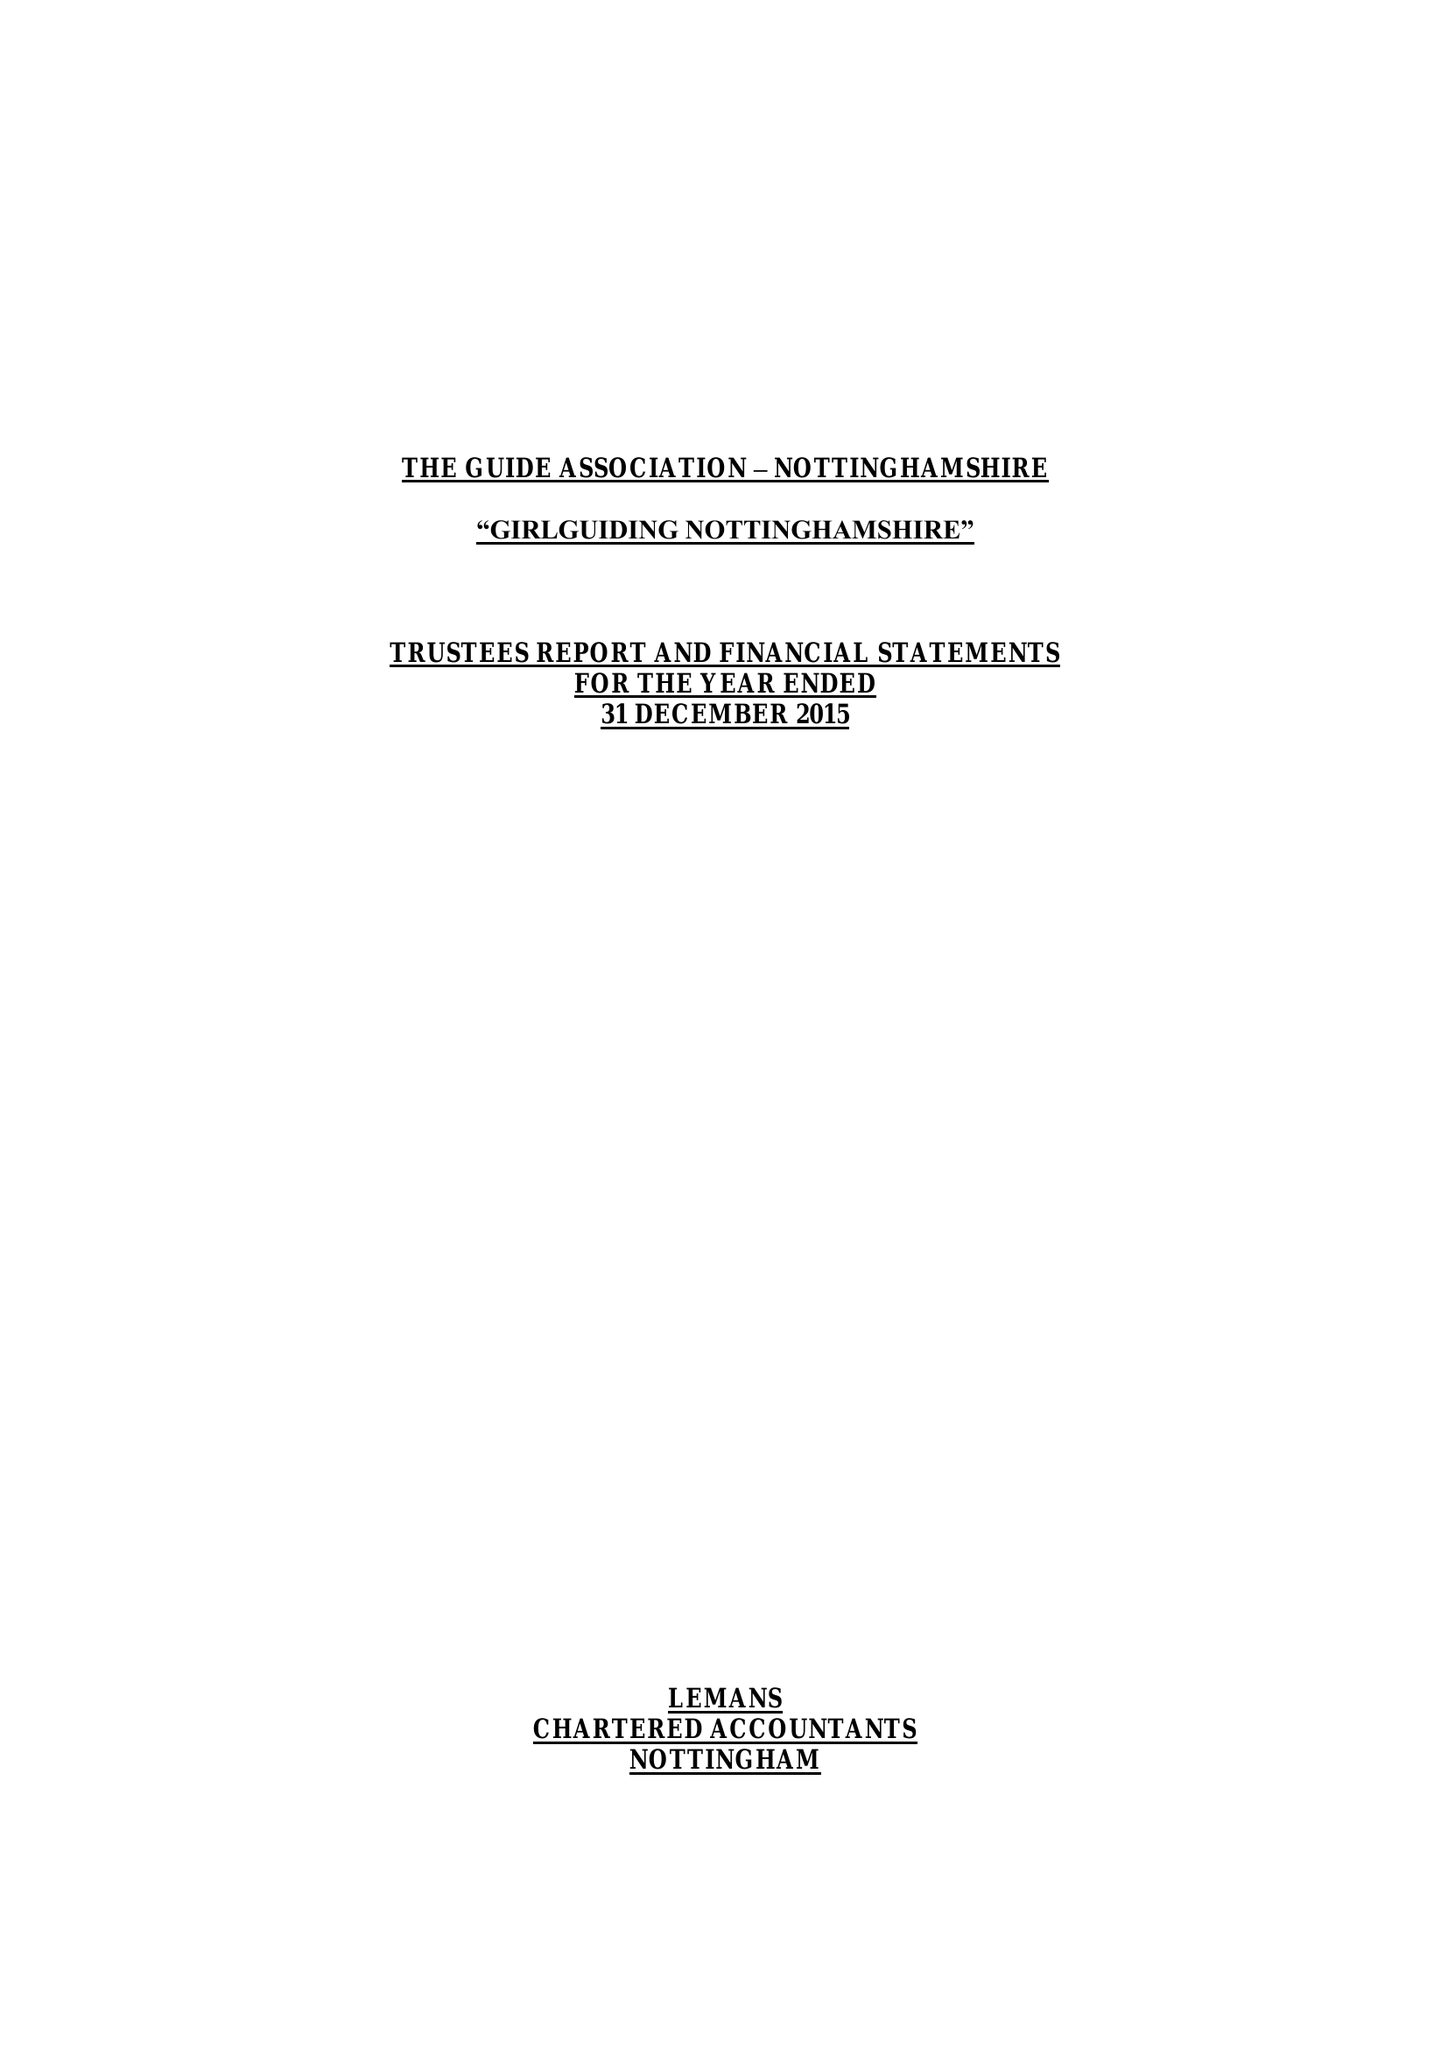What is the value for the charity_name?
Answer the question using a single word or phrase. The Guide Association - Nottinghamshire County 